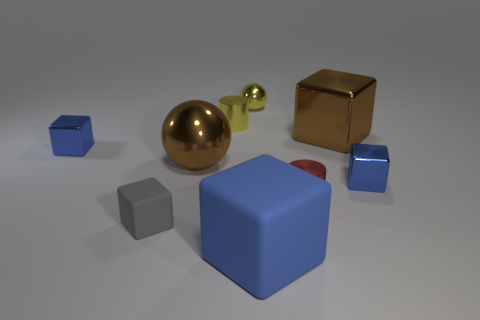How many big purple metal things are there?
Keep it short and to the point. 0. Is the size of the blue matte block the same as the gray object?
Give a very brief answer. No. What number of other things are the same shape as the gray thing?
Provide a short and direct response. 4. What material is the blue thing in front of the matte cube left of the large rubber block made of?
Your answer should be compact. Rubber. There is a tiny gray thing; are there any big blocks in front of it?
Ensure brevity in your answer.  Yes. Do the brown metal ball and the gray rubber cube in front of the tiny yellow metal sphere have the same size?
Give a very brief answer. No. What size is the other brown object that is the same shape as the large rubber thing?
Ensure brevity in your answer.  Large. Is there anything else that is the same material as the tiny yellow sphere?
Your answer should be very brief. Yes. Do the blue cube that is to the left of the big matte object and the brown thing in front of the large brown shiny cube have the same size?
Keep it short and to the point. No. How many tiny objects are either yellow balls or gray rubber objects?
Give a very brief answer. 2. 